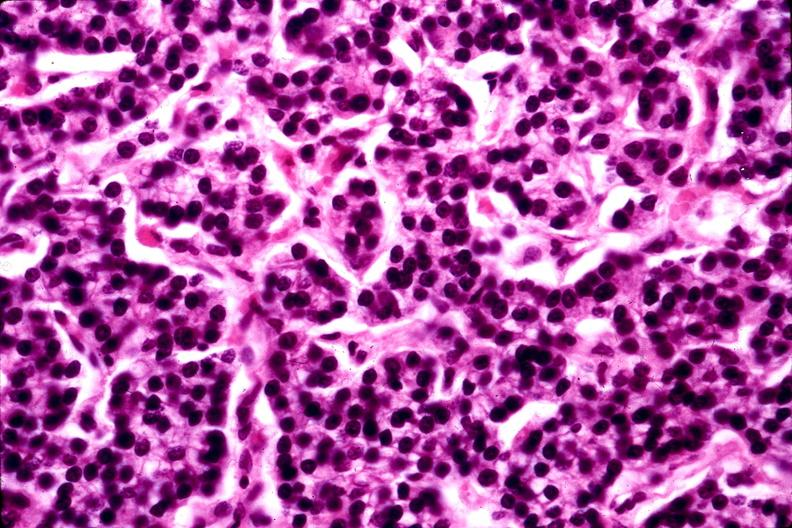does angiogram show parathyroid adenoma?
Answer the question using a single word or phrase. No 